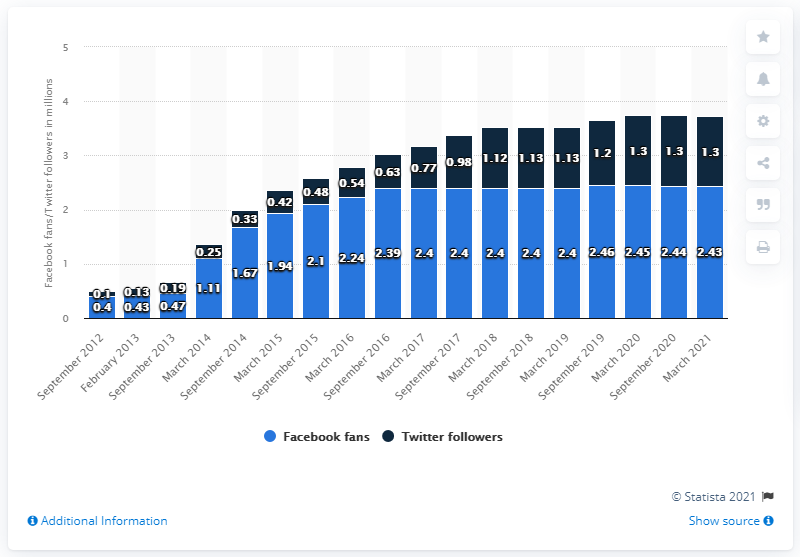List a handful of essential elements in this visual. In March 2021, the Portland Trail Blazers Facebook page had 2,430 people engaged with their content. 